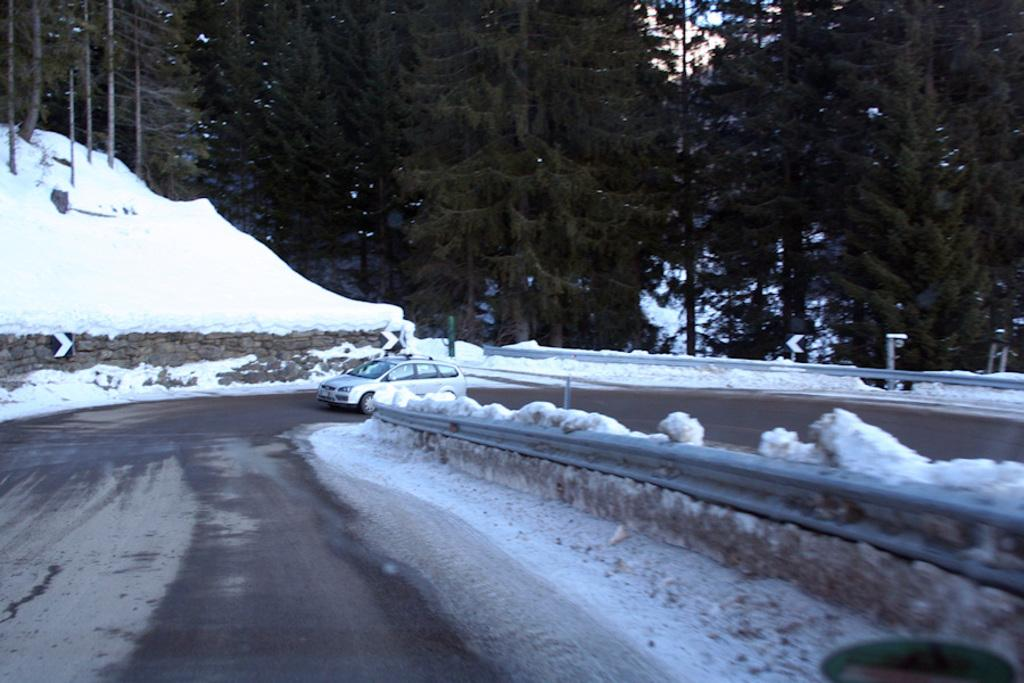What is the main feature of the image? There is a road in the image. What is on the road? There is a car on the road. What can be seen in the background of the image? There are trees and snow visible in the background. What else is visible in the background of the image? The sky is visible in the background of the image. What type of trade is being conducted in the image? There is no indication of any trade being conducted in the image; it primarily features a road, a car, and the background. What ideas are being exchanged in the image? There is no indication of any ideas being exchanged in the image; it primarily features a road, a car, and the background. 